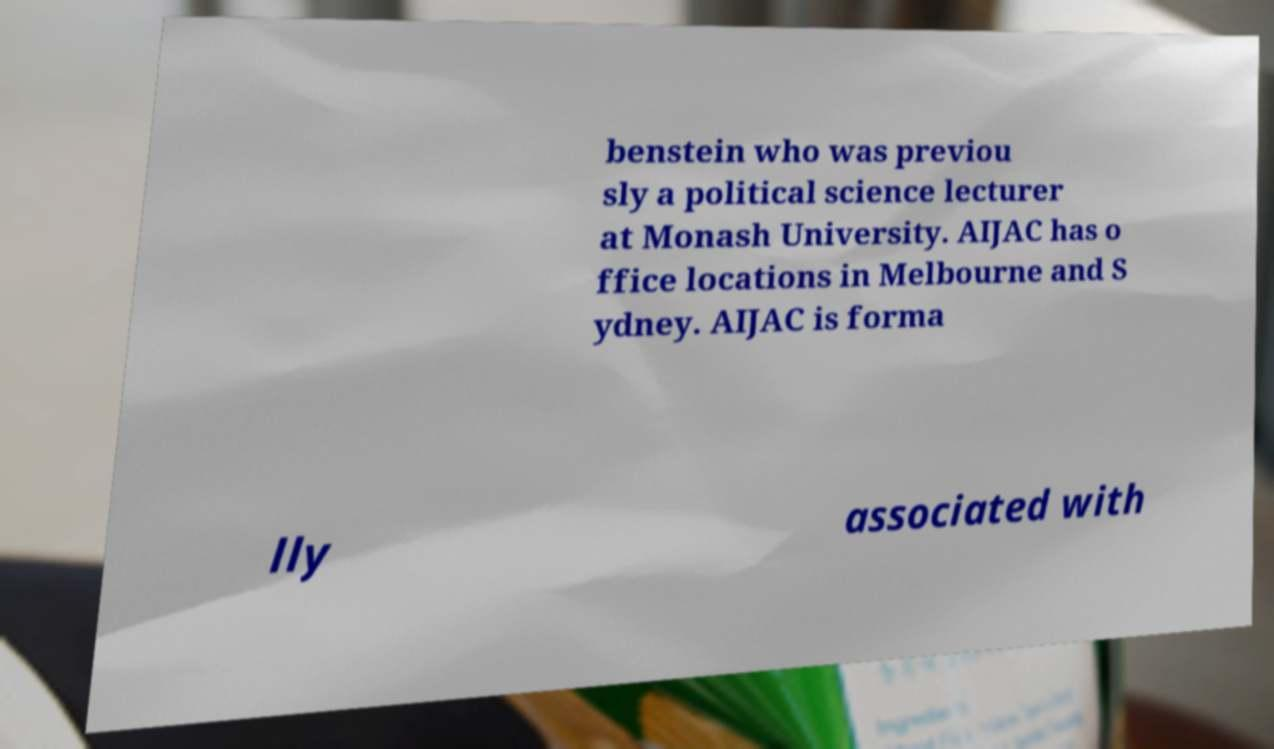Could you extract and type out the text from this image? benstein who was previou sly a political science lecturer at Monash University. AIJAC has o ffice locations in Melbourne and S ydney. AIJAC is forma lly associated with 